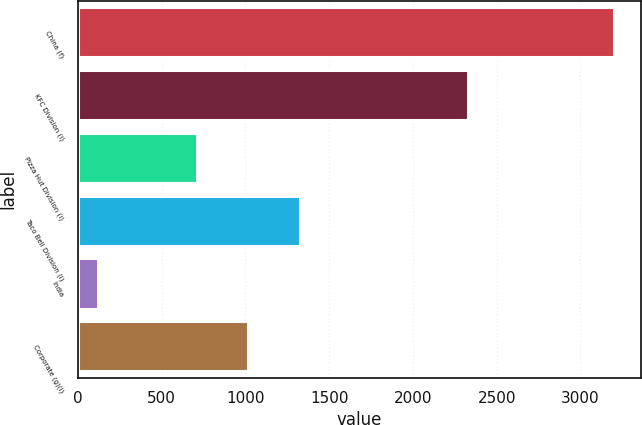<chart> <loc_0><loc_0><loc_500><loc_500><bar_chart><fcel>China (f)<fcel>KFC Division (i)<fcel>Pizza Hut Division (i)<fcel>Taco Bell Division (i)<fcel>India<fcel>Corporate (g)(i)<nl><fcel>3202<fcel>2328<fcel>710<fcel>1326.8<fcel>118<fcel>1018.4<nl></chart> 